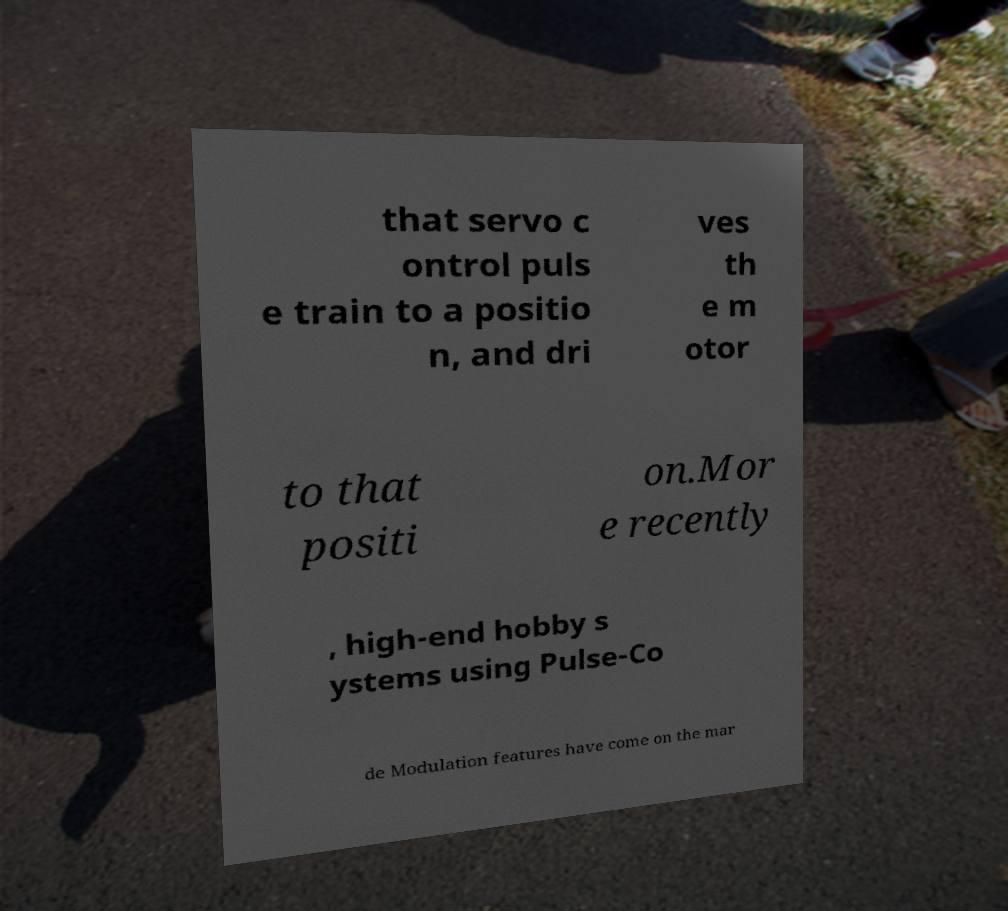Could you assist in decoding the text presented in this image and type it out clearly? that servo c ontrol puls e train to a positio n, and dri ves th e m otor to that positi on.Mor e recently , high-end hobby s ystems using Pulse-Co de Modulation features have come on the mar 